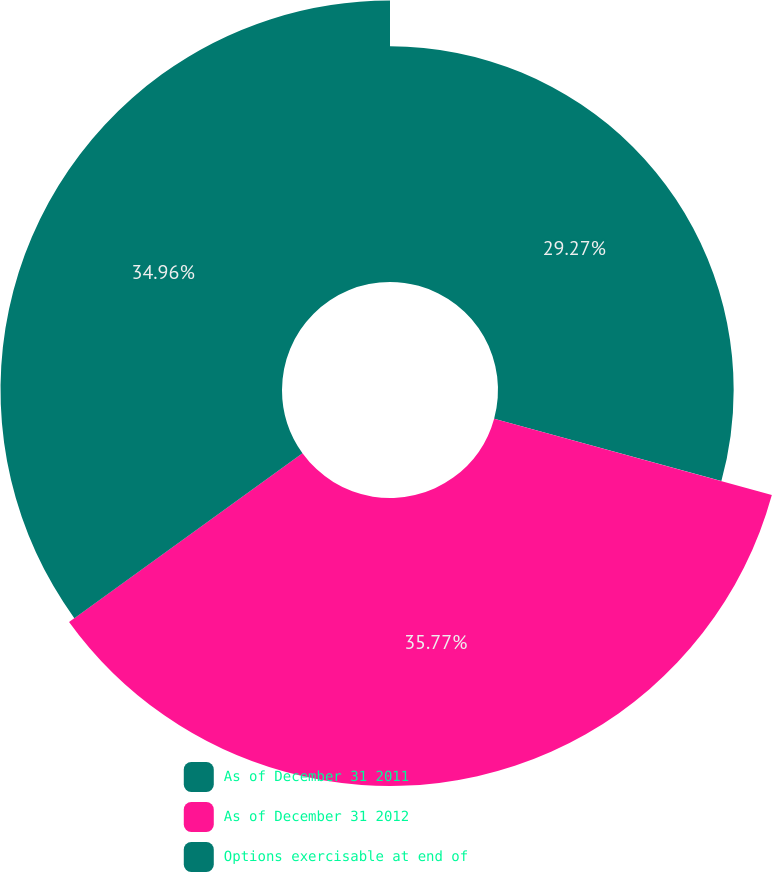Convert chart. <chart><loc_0><loc_0><loc_500><loc_500><pie_chart><fcel>As of December 31 2011<fcel>As of December 31 2012<fcel>Options exercisable at end of<nl><fcel>29.27%<fcel>35.77%<fcel>34.96%<nl></chart> 